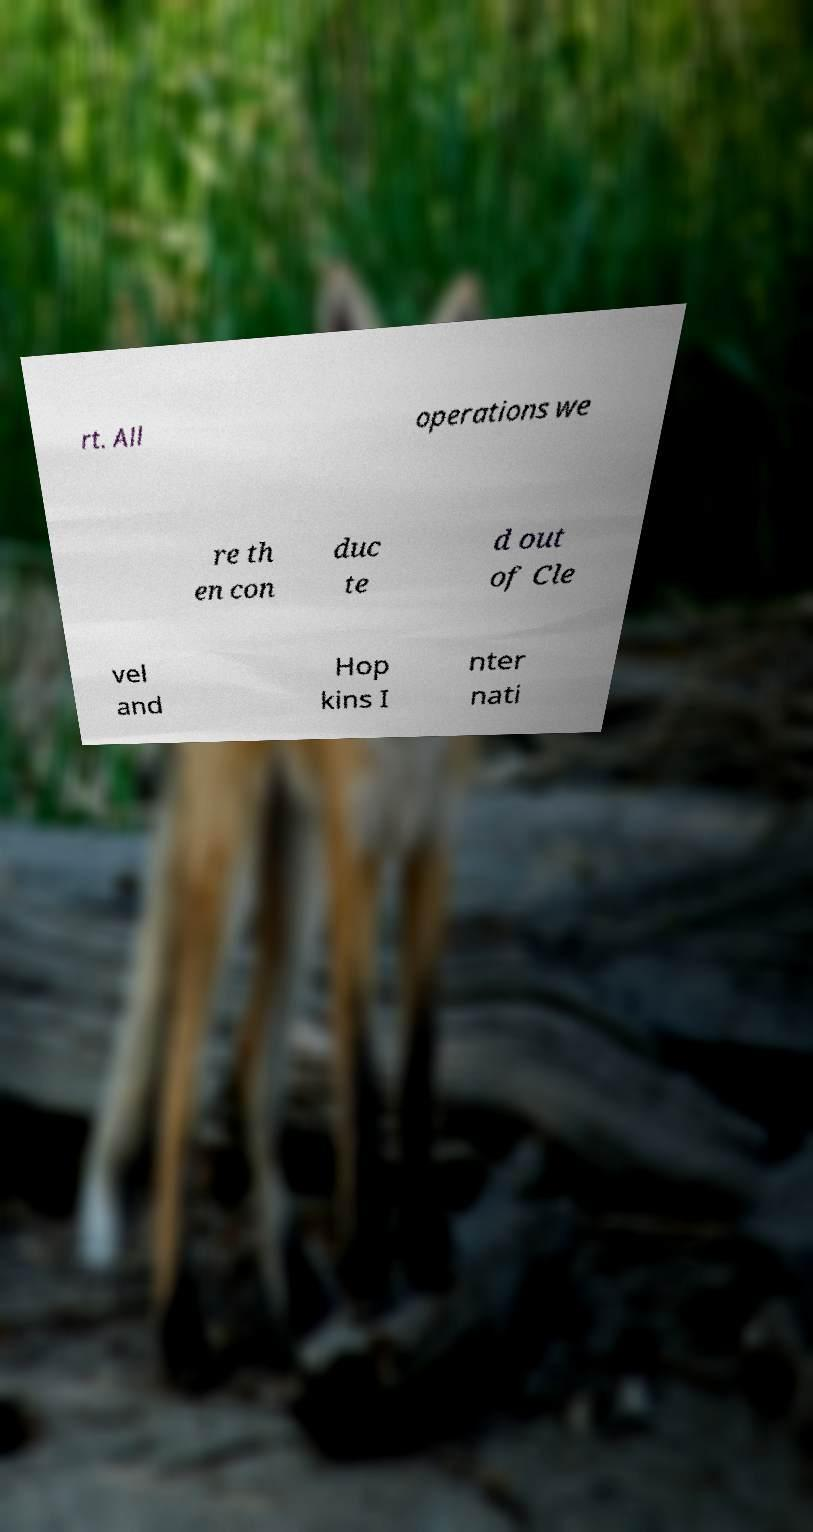Can you accurately transcribe the text from the provided image for me? rt. All operations we re th en con duc te d out of Cle vel and Hop kins I nter nati 